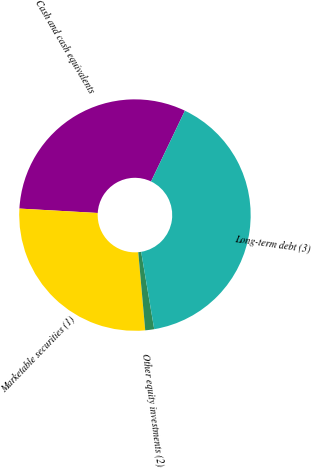Convert chart. <chart><loc_0><loc_0><loc_500><loc_500><pie_chart><fcel>Cash and cash equivalents<fcel>Marketable securities (1)<fcel>Other equity investments (2)<fcel>Long-term debt (3)<nl><fcel>31.21%<fcel>27.31%<fcel>1.25%<fcel>40.23%<nl></chart> 